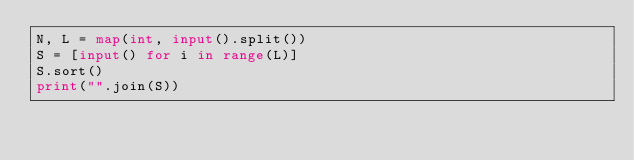<code> <loc_0><loc_0><loc_500><loc_500><_Python_>N, L = map(int, input().split())
S = [input() for i in range(L)]
S.sort()
print("".join(S))</code> 